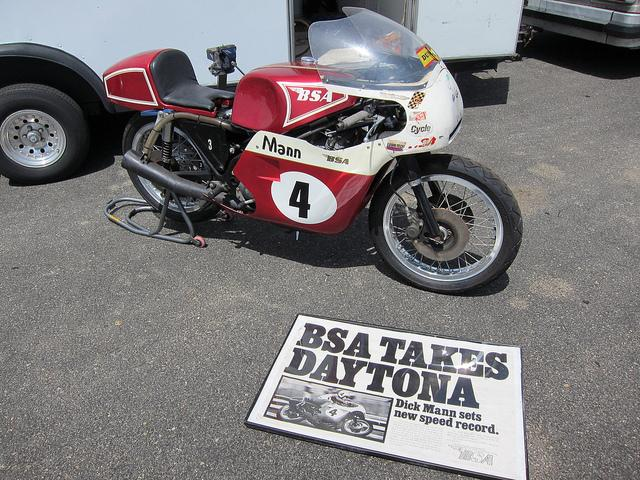What is the first name of the person who rode this bike? Please explain your reasoning. dick. The name is dick. 